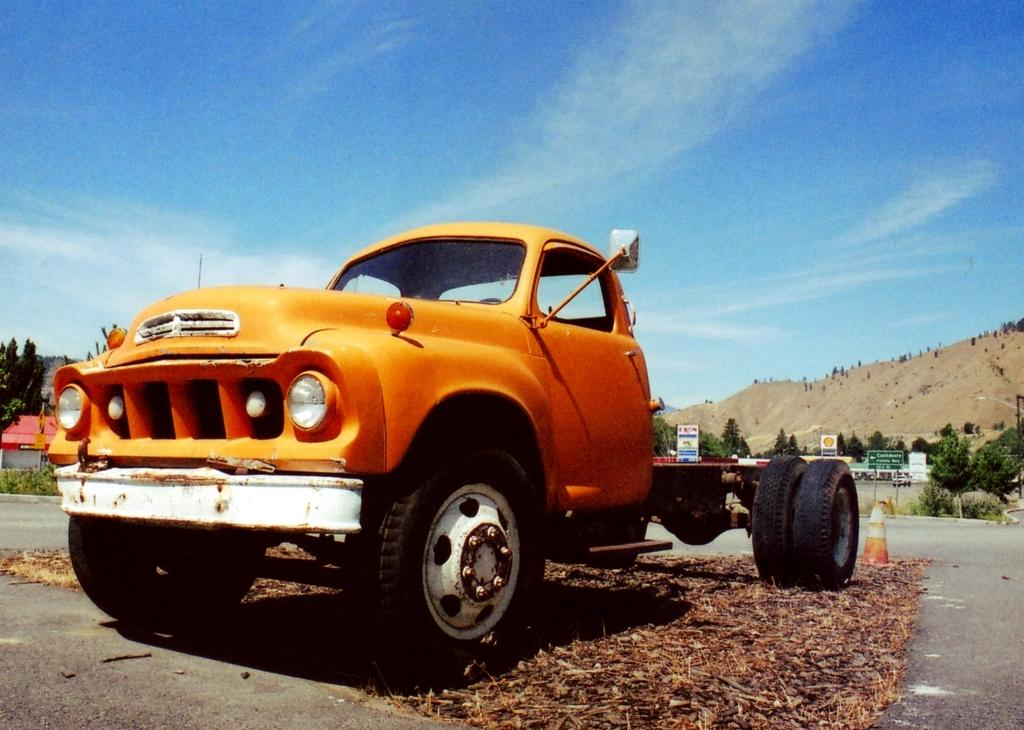What is the main subject of the image? The main subject of the image is a truck. What can be seen in the background of the image? There are trees, buildings, and a hill visible in the background of the image. Are there any signs or messages in the image? Yes, there are boards with text in the image. What type of vegetation is present in the image? There are plants in the image. How would you describe the sky in the image? The sky is blue and cloudy in the image. What type of treatment is the father receiving from the expert in the image? There is no father or expert present in the image, and therefore no such treatment can be observed. 